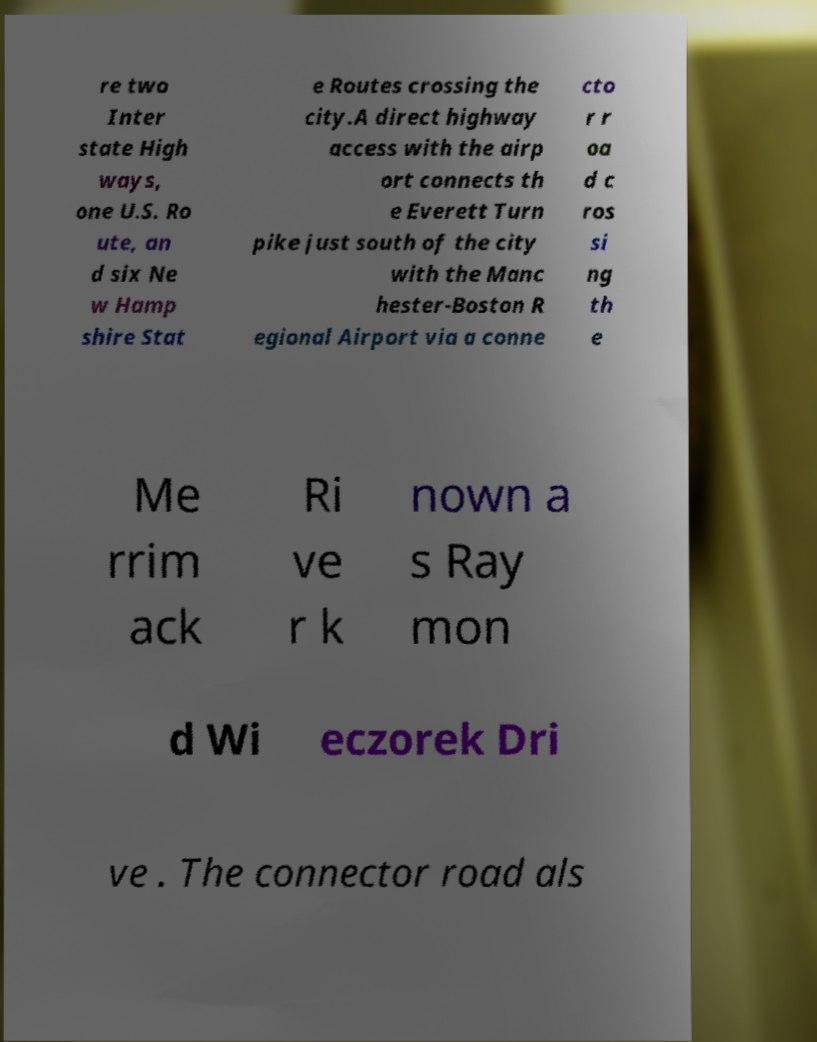For documentation purposes, I need the text within this image transcribed. Could you provide that? re two Inter state High ways, one U.S. Ro ute, an d six Ne w Hamp shire Stat e Routes crossing the city.A direct highway access with the airp ort connects th e Everett Turn pike just south of the city with the Manc hester-Boston R egional Airport via a conne cto r r oa d c ros si ng th e Me rrim ack Ri ve r k nown a s Ray mon d Wi eczorek Dri ve . The connector road als 